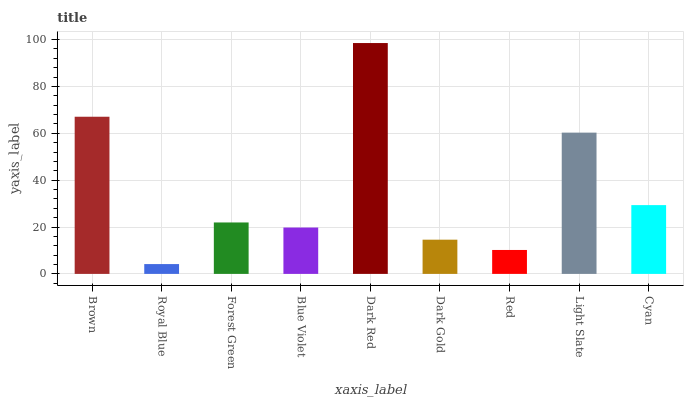Is Royal Blue the minimum?
Answer yes or no. Yes. Is Dark Red the maximum?
Answer yes or no. Yes. Is Forest Green the minimum?
Answer yes or no. No. Is Forest Green the maximum?
Answer yes or no. No. Is Forest Green greater than Royal Blue?
Answer yes or no. Yes. Is Royal Blue less than Forest Green?
Answer yes or no. Yes. Is Royal Blue greater than Forest Green?
Answer yes or no. No. Is Forest Green less than Royal Blue?
Answer yes or no. No. Is Forest Green the high median?
Answer yes or no. Yes. Is Forest Green the low median?
Answer yes or no. Yes. Is Light Slate the high median?
Answer yes or no. No. Is Blue Violet the low median?
Answer yes or no. No. 